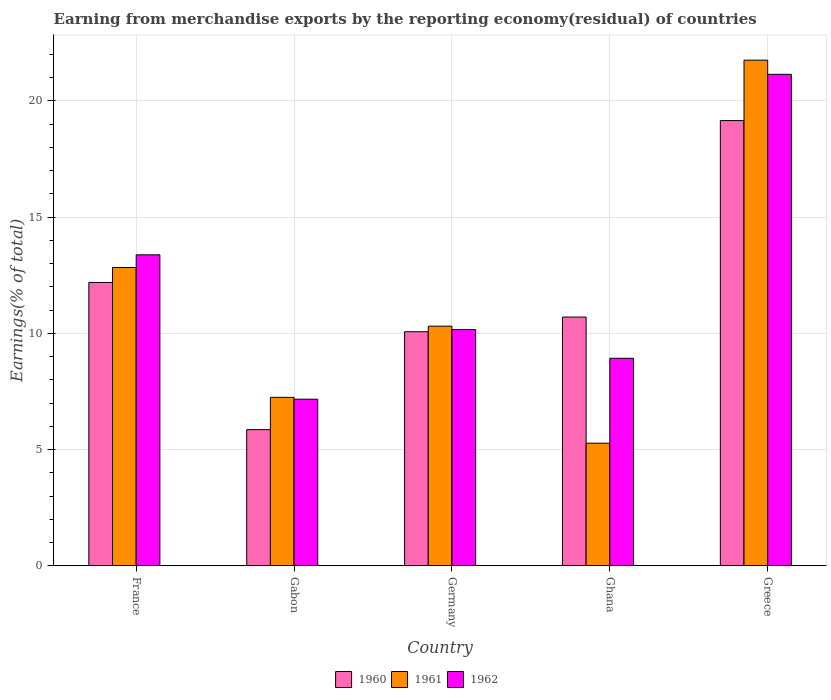How many different coloured bars are there?
Your response must be concise. 3. How many bars are there on the 1st tick from the left?
Make the answer very short. 3. How many bars are there on the 2nd tick from the right?
Make the answer very short. 3. What is the label of the 1st group of bars from the left?
Keep it short and to the point. France. In how many cases, is the number of bars for a given country not equal to the number of legend labels?
Keep it short and to the point. 0. What is the percentage of amount earned from merchandise exports in 1960 in Gabon?
Your answer should be very brief. 5.86. Across all countries, what is the maximum percentage of amount earned from merchandise exports in 1961?
Make the answer very short. 21.75. Across all countries, what is the minimum percentage of amount earned from merchandise exports in 1961?
Your answer should be compact. 5.27. In which country was the percentage of amount earned from merchandise exports in 1961 maximum?
Provide a succinct answer. Greece. In which country was the percentage of amount earned from merchandise exports in 1962 minimum?
Keep it short and to the point. Gabon. What is the total percentage of amount earned from merchandise exports in 1960 in the graph?
Make the answer very short. 57.97. What is the difference between the percentage of amount earned from merchandise exports in 1960 in France and that in Greece?
Give a very brief answer. -6.96. What is the difference between the percentage of amount earned from merchandise exports in 1961 in Gabon and the percentage of amount earned from merchandise exports in 1960 in Greece?
Your answer should be very brief. -11.91. What is the average percentage of amount earned from merchandise exports in 1961 per country?
Offer a terse response. 11.48. What is the difference between the percentage of amount earned from merchandise exports of/in 1961 and percentage of amount earned from merchandise exports of/in 1960 in Germany?
Provide a succinct answer. 0.24. In how many countries, is the percentage of amount earned from merchandise exports in 1960 greater than 5 %?
Provide a succinct answer. 5. What is the ratio of the percentage of amount earned from merchandise exports in 1962 in Germany to that in Ghana?
Provide a short and direct response. 1.14. Is the percentage of amount earned from merchandise exports in 1960 in France less than that in Gabon?
Your answer should be very brief. No. Is the difference between the percentage of amount earned from merchandise exports in 1961 in Gabon and Germany greater than the difference between the percentage of amount earned from merchandise exports in 1960 in Gabon and Germany?
Make the answer very short. Yes. What is the difference between the highest and the second highest percentage of amount earned from merchandise exports in 1961?
Keep it short and to the point. -2.53. What is the difference between the highest and the lowest percentage of amount earned from merchandise exports in 1960?
Provide a succinct answer. 13.3. Is the sum of the percentage of amount earned from merchandise exports in 1961 in Ghana and Greece greater than the maximum percentage of amount earned from merchandise exports in 1960 across all countries?
Provide a short and direct response. Yes. What does the 1st bar from the left in Germany represents?
Your response must be concise. 1960. What does the 2nd bar from the right in Greece represents?
Your answer should be compact. 1961. What is the difference between two consecutive major ticks on the Y-axis?
Make the answer very short. 5. Are the values on the major ticks of Y-axis written in scientific E-notation?
Provide a short and direct response. No. Does the graph contain grids?
Keep it short and to the point. Yes. Where does the legend appear in the graph?
Offer a terse response. Bottom center. How many legend labels are there?
Ensure brevity in your answer.  3. What is the title of the graph?
Keep it short and to the point. Earning from merchandise exports by the reporting economy(residual) of countries. Does "1971" appear as one of the legend labels in the graph?
Keep it short and to the point. No. What is the label or title of the X-axis?
Ensure brevity in your answer.  Country. What is the label or title of the Y-axis?
Keep it short and to the point. Earnings(% of total). What is the Earnings(% of total) in 1960 in France?
Provide a short and direct response. 12.19. What is the Earnings(% of total) of 1961 in France?
Your answer should be very brief. 12.83. What is the Earnings(% of total) of 1962 in France?
Keep it short and to the point. 13.38. What is the Earnings(% of total) of 1960 in Gabon?
Your answer should be very brief. 5.86. What is the Earnings(% of total) of 1961 in Gabon?
Your answer should be compact. 7.25. What is the Earnings(% of total) in 1962 in Gabon?
Give a very brief answer. 7.17. What is the Earnings(% of total) of 1960 in Germany?
Your answer should be very brief. 10.07. What is the Earnings(% of total) of 1961 in Germany?
Your answer should be very brief. 10.31. What is the Earnings(% of total) of 1962 in Germany?
Offer a terse response. 10.16. What is the Earnings(% of total) of 1960 in Ghana?
Provide a short and direct response. 10.7. What is the Earnings(% of total) in 1961 in Ghana?
Give a very brief answer. 5.27. What is the Earnings(% of total) in 1962 in Ghana?
Offer a terse response. 8.93. What is the Earnings(% of total) in 1960 in Greece?
Your answer should be compact. 19.15. What is the Earnings(% of total) in 1961 in Greece?
Your answer should be compact. 21.75. What is the Earnings(% of total) in 1962 in Greece?
Offer a very short reply. 21.14. Across all countries, what is the maximum Earnings(% of total) in 1960?
Provide a succinct answer. 19.15. Across all countries, what is the maximum Earnings(% of total) of 1961?
Offer a very short reply. 21.75. Across all countries, what is the maximum Earnings(% of total) of 1962?
Provide a succinct answer. 21.14. Across all countries, what is the minimum Earnings(% of total) in 1960?
Provide a succinct answer. 5.86. Across all countries, what is the minimum Earnings(% of total) of 1961?
Provide a short and direct response. 5.27. Across all countries, what is the minimum Earnings(% of total) in 1962?
Ensure brevity in your answer.  7.17. What is the total Earnings(% of total) of 1960 in the graph?
Offer a terse response. 57.97. What is the total Earnings(% of total) of 1961 in the graph?
Provide a succinct answer. 57.42. What is the total Earnings(% of total) of 1962 in the graph?
Your answer should be very brief. 60.78. What is the difference between the Earnings(% of total) in 1960 in France and that in Gabon?
Provide a succinct answer. 6.33. What is the difference between the Earnings(% of total) of 1961 in France and that in Gabon?
Provide a short and direct response. 5.59. What is the difference between the Earnings(% of total) of 1962 in France and that in Gabon?
Your response must be concise. 6.21. What is the difference between the Earnings(% of total) in 1960 in France and that in Germany?
Your answer should be very brief. 2.12. What is the difference between the Earnings(% of total) of 1961 in France and that in Germany?
Ensure brevity in your answer.  2.53. What is the difference between the Earnings(% of total) of 1962 in France and that in Germany?
Provide a short and direct response. 3.22. What is the difference between the Earnings(% of total) of 1960 in France and that in Ghana?
Make the answer very short. 1.49. What is the difference between the Earnings(% of total) of 1961 in France and that in Ghana?
Your answer should be very brief. 7.56. What is the difference between the Earnings(% of total) in 1962 in France and that in Ghana?
Ensure brevity in your answer.  4.45. What is the difference between the Earnings(% of total) in 1960 in France and that in Greece?
Your answer should be compact. -6.96. What is the difference between the Earnings(% of total) in 1961 in France and that in Greece?
Ensure brevity in your answer.  -8.92. What is the difference between the Earnings(% of total) in 1962 in France and that in Greece?
Provide a succinct answer. -7.76. What is the difference between the Earnings(% of total) in 1960 in Gabon and that in Germany?
Make the answer very short. -4.21. What is the difference between the Earnings(% of total) in 1961 in Gabon and that in Germany?
Your response must be concise. -3.06. What is the difference between the Earnings(% of total) of 1962 in Gabon and that in Germany?
Keep it short and to the point. -3. What is the difference between the Earnings(% of total) of 1960 in Gabon and that in Ghana?
Ensure brevity in your answer.  -4.84. What is the difference between the Earnings(% of total) in 1961 in Gabon and that in Ghana?
Offer a very short reply. 1.97. What is the difference between the Earnings(% of total) in 1962 in Gabon and that in Ghana?
Provide a succinct answer. -1.76. What is the difference between the Earnings(% of total) of 1960 in Gabon and that in Greece?
Make the answer very short. -13.3. What is the difference between the Earnings(% of total) of 1961 in Gabon and that in Greece?
Provide a succinct answer. -14.51. What is the difference between the Earnings(% of total) in 1962 in Gabon and that in Greece?
Ensure brevity in your answer.  -13.98. What is the difference between the Earnings(% of total) in 1960 in Germany and that in Ghana?
Provide a short and direct response. -0.63. What is the difference between the Earnings(% of total) in 1961 in Germany and that in Ghana?
Your answer should be very brief. 5.03. What is the difference between the Earnings(% of total) in 1962 in Germany and that in Ghana?
Provide a short and direct response. 1.24. What is the difference between the Earnings(% of total) in 1960 in Germany and that in Greece?
Keep it short and to the point. -9.08. What is the difference between the Earnings(% of total) of 1961 in Germany and that in Greece?
Offer a terse response. -11.44. What is the difference between the Earnings(% of total) of 1962 in Germany and that in Greece?
Your answer should be very brief. -10.98. What is the difference between the Earnings(% of total) of 1960 in Ghana and that in Greece?
Your answer should be compact. -8.45. What is the difference between the Earnings(% of total) of 1961 in Ghana and that in Greece?
Your answer should be compact. -16.48. What is the difference between the Earnings(% of total) of 1962 in Ghana and that in Greece?
Your answer should be very brief. -12.22. What is the difference between the Earnings(% of total) of 1960 in France and the Earnings(% of total) of 1961 in Gabon?
Make the answer very short. 4.94. What is the difference between the Earnings(% of total) of 1960 in France and the Earnings(% of total) of 1962 in Gabon?
Give a very brief answer. 5.02. What is the difference between the Earnings(% of total) of 1961 in France and the Earnings(% of total) of 1962 in Gabon?
Your response must be concise. 5.67. What is the difference between the Earnings(% of total) of 1960 in France and the Earnings(% of total) of 1961 in Germany?
Provide a succinct answer. 1.88. What is the difference between the Earnings(% of total) in 1960 in France and the Earnings(% of total) in 1962 in Germany?
Offer a very short reply. 2.03. What is the difference between the Earnings(% of total) in 1961 in France and the Earnings(% of total) in 1962 in Germany?
Give a very brief answer. 2.67. What is the difference between the Earnings(% of total) of 1960 in France and the Earnings(% of total) of 1961 in Ghana?
Provide a succinct answer. 6.91. What is the difference between the Earnings(% of total) in 1960 in France and the Earnings(% of total) in 1962 in Ghana?
Ensure brevity in your answer.  3.26. What is the difference between the Earnings(% of total) in 1961 in France and the Earnings(% of total) in 1962 in Ghana?
Offer a very short reply. 3.91. What is the difference between the Earnings(% of total) of 1960 in France and the Earnings(% of total) of 1961 in Greece?
Ensure brevity in your answer.  -9.56. What is the difference between the Earnings(% of total) in 1960 in France and the Earnings(% of total) in 1962 in Greece?
Keep it short and to the point. -8.95. What is the difference between the Earnings(% of total) of 1961 in France and the Earnings(% of total) of 1962 in Greece?
Ensure brevity in your answer.  -8.31. What is the difference between the Earnings(% of total) of 1960 in Gabon and the Earnings(% of total) of 1961 in Germany?
Give a very brief answer. -4.45. What is the difference between the Earnings(% of total) in 1960 in Gabon and the Earnings(% of total) in 1962 in Germany?
Offer a terse response. -4.3. What is the difference between the Earnings(% of total) in 1961 in Gabon and the Earnings(% of total) in 1962 in Germany?
Make the answer very short. -2.92. What is the difference between the Earnings(% of total) in 1960 in Gabon and the Earnings(% of total) in 1961 in Ghana?
Offer a terse response. 0.58. What is the difference between the Earnings(% of total) in 1960 in Gabon and the Earnings(% of total) in 1962 in Ghana?
Ensure brevity in your answer.  -3.07. What is the difference between the Earnings(% of total) in 1961 in Gabon and the Earnings(% of total) in 1962 in Ghana?
Keep it short and to the point. -1.68. What is the difference between the Earnings(% of total) in 1960 in Gabon and the Earnings(% of total) in 1961 in Greece?
Offer a very short reply. -15.9. What is the difference between the Earnings(% of total) of 1960 in Gabon and the Earnings(% of total) of 1962 in Greece?
Make the answer very short. -15.29. What is the difference between the Earnings(% of total) in 1961 in Gabon and the Earnings(% of total) in 1962 in Greece?
Your answer should be compact. -13.9. What is the difference between the Earnings(% of total) in 1960 in Germany and the Earnings(% of total) in 1961 in Ghana?
Make the answer very short. 4.79. What is the difference between the Earnings(% of total) of 1960 in Germany and the Earnings(% of total) of 1962 in Ghana?
Your answer should be very brief. 1.14. What is the difference between the Earnings(% of total) in 1961 in Germany and the Earnings(% of total) in 1962 in Ghana?
Give a very brief answer. 1.38. What is the difference between the Earnings(% of total) of 1960 in Germany and the Earnings(% of total) of 1961 in Greece?
Offer a very short reply. -11.68. What is the difference between the Earnings(% of total) of 1960 in Germany and the Earnings(% of total) of 1962 in Greece?
Provide a short and direct response. -11.07. What is the difference between the Earnings(% of total) in 1961 in Germany and the Earnings(% of total) in 1962 in Greece?
Keep it short and to the point. -10.84. What is the difference between the Earnings(% of total) of 1960 in Ghana and the Earnings(% of total) of 1961 in Greece?
Provide a succinct answer. -11.05. What is the difference between the Earnings(% of total) in 1960 in Ghana and the Earnings(% of total) in 1962 in Greece?
Your answer should be very brief. -10.44. What is the difference between the Earnings(% of total) of 1961 in Ghana and the Earnings(% of total) of 1962 in Greece?
Your response must be concise. -15.87. What is the average Earnings(% of total) in 1960 per country?
Keep it short and to the point. 11.59. What is the average Earnings(% of total) in 1961 per country?
Offer a terse response. 11.48. What is the average Earnings(% of total) in 1962 per country?
Ensure brevity in your answer.  12.16. What is the difference between the Earnings(% of total) of 1960 and Earnings(% of total) of 1961 in France?
Provide a short and direct response. -0.64. What is the difference between the Earnings(% of total) of 1960 and Earnings(% of total) of 1962 in France?
Offer a very short reply. -1.19. What is the difference between the Earnings(% of total) of 1961 and Earnings(% of total) of 1962 in France?
Make the answer very short. -0.55. What is the difference between the Earnings(% of total) in 1960 and Earnings(% of total) in 1961 in Gabon?
Offer a terse response. -1.39. What is the difference between the Earnings(% of total) in 1960 and Earnings(% of total) in 1962 in Gabon?
Your answer should be very brief. -1.31. What is the difference between the Earnings(% of total) of 1961 and Earnings(% of total) of 1962 in Gabon?
Make the answer very short. 0.08. What is the difference between the Earnings(% of total) of 1960 and Earnings(% of total) of 1961 in Germany?
Keep it short and to the point. -0.24. What is the difference between the Earnings(% of total) of 1960 and Earnings(% of total) of 1962 in Germany?
Give a very brief answer. -0.09. What is the difference between the Earnings(% of total) in 1961 and Earnings(% of total) in 1962 in Germany?
Provide a succinct answer. 0.15. What is the difference between the Earnings(% of total) of 1960 and Earnings(% of total) of 1961 in Ghana?
Provide a short and direct response. 5.43. What is the difference between the Earnings(% of total) of 1960 and Earnings(% of total) of 1962 in Ghana?
Keep it short and to the point. 1.77. What is the difference between the Earnings(% of total) in 1961 and Earnings(% of total) in 1962 in Ghana?
Offer a very short reply. -3.65. What is the difference between the Earnings(% of total) in 1960 and Earnings(% of total) in 1961 in Greece?
Offer a terse response. -2.6. What is the difference between the Earnings(% of total) of 1960 and Earnings(% of total) of 1962 in Greece?
Ensure brevity in your answer.  -1.99. What is the difference between the Earnings(% of total) of 1961 and Earnings(% of total) of 1962 in Greece?
Ensure brevity in your answer.  0.61. What is the ratio of the Earnings(% of total) of 1960 in France to that in Gabon?
Offer a very short reply. 2.08. What is the ratio of the Earnings(% of total) of 1961 in France to that in Gabon?
Keep it short and to the point. 1.77. What is the ratio of the Earnings(% of total) in 1962 in France to that in Gabon?
Keep it short and to the point. 1.87. What is the ratio of the Earnings(% of total) of 1960 in France to that in Germany?
Your response must be concise. 1.21. What is the ratio of the Earnings(% of total) in 1961 in France to that in Germany?
Make the answer very short. 1.25. What is the ratio of the Earnings(% of total) of 1962 in France to that in Germany?
Keep it short and to the point. 1.32. What is the ratio of the Earnings(% of total) of 1960 in France to that in Ghana?
Your answer should be very brief. 1.14. What is the ratio of the Earnings(% of total) of 1961 in France to that in Ghana?
Make the answer very short. 2.43. What is the ratio of the Earnings(% of total) of 1962 in France to that in Ghana?
Provide a short and direct response. 1.5. What is the ratio of the Earnings(% of total) of 1960 in France to that in Greece?
Your answer should be very brief. 0.64. What is the ratio of the Earnings(% of total) in 1961 in France to that in Greece?
Give a very brief answer. 0.59. What is the ratio of the Earnings(% of total) of 1962 in France to that in Greece?
Offer a terse response. 0.63. What is the ratio of the Earnings(% of total) of 1960 in Gabon to that in Germany?
Give a very brief answer. 0.58. What is the ratio of the Earnings(% of total) in 1961 in Gabon to that in Germany?
Your answer should be very brief. 0.7. What is the ratio of the Earnings(% of total) in 1962 in Gabon to that in Germany?
Your answer should be very brief. 0.71. What is the ratio of the Earnings(% of total) of 1960 in Gabon to that in Ghana?
Your response must be concise. 0.55. What is the ratio of the Earnings(% of total) of 1961 in Gabon to that in Ghana?
Offer a very short reply. 1.37. What is the ratio of the Earnings(% of total) in 1962 in Gabon to that in Ghana?
Give a very brief answer. 0.8. What is the ratio of the Earnings(% of total) of 1960 in Gabon to that in Greece?
Your answer should be compact. 0.31. What is the ratio of the Earnings(% of total) in 1961 in Gabon to that in Greece?
Offer a terse response. 0.33. What is the ratio of the Earnings(% of total) of 1962 in Gabon to that in Greece?
Your answer should be compact. 0.34. What is the ratio of the Earnings(% of total) of 1960 in Germany to that in Ghana?
Keep it short and to the point. 0.94. What is the ratio of the Earnings(% of total) of 1961 in Germany to that in Ghana?
Offer a very short reply. 1.95. What is the ratio of the Earnings(% of total) of 1962 in Germany to that in Ghana?
Keep it short and to the point. 1.14. What is the ratio of the Earnings(% of total) of 1960 in Germany to that in Greece?
Ensure brevity in your answer.  0.53. What is the ratio of the Earnings(% of total) of 1961 in Germany to that in Greece?
Provide a short and direct response. 0.47. What is the ratio of the Earnings(% of total) in 1962 in Germany to that in Greece?
Offer a terse response. 0.48. What is the ratio of the Earnings(% of total) of 1960 in Ghana to that in Greece?
Give a very brief answer. 0.56. What is the ratio of the Earnings(% of total) of 1961 in Ghana to that in Greece?
Provide a succinct answer. 0.24. What is the ratio of the Earnings(% of total) of 1962 in Ghana to that in Greece?
Your answer should be compact. 0.42. What is the difference between the highest and the second highest Earnings(% of total) in 1960?
Your response must be concise. 6.96. What is the difference between the highest and the second highest Earnings(% of total) of 1961?
Provide a succinct answer. 8.92. What is the difference between the highest and the second highest Earnings(% of total) of 1962?
Offer a terse response. 7.76. What is the difference between the highest and the lowest Earnings(% of total) of 1960?
Offer a terse response. 13.3. What is the difference between the highest and the lowest Earnings(% of total) in 1961?
Your answer should be compact. 16.48. What is the difference between the highest and the lowest Earnings(% of total) of 1962?
Offer a terse response. 13.98. 